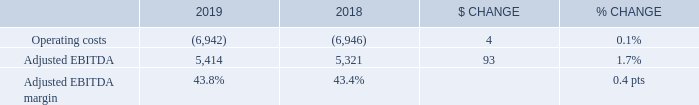OPERATING COSTS AND ADJUSTED EBITDA
Bell Wireline operating costs were essentially stable year over year, decreasing by 0.1% in 2019, compared to 2018, resulting from: • The favourable impact from the adoption of IFRS 16 in 2019 • Continued effective cost containment • Lower pension expenses reflecting reduced DB costs
These factors were partly offset by: • Higher cost of goods sold related to the growth in product sales • Increased costs from the acquisition of Axia • Greater payments to other carriers from increased sales of international wholesale long distance minutes
Bell Wireline adjusted EBITDA grew by 1.7% in 2019, compared to last year, reflecting the growth in revenues as operating expenses were relatively stable year over year. Adjusted EBITDA margin increased to 43.8% in 2019, compared to the 43.4% achieved last year, resulting from the favourable impact of the adoption of IFRS 16 in 2019 and the flow-through of the service revenue growth, offset in part by higher low-margin product sales in our total revenue base.
What are the favourable impact from the adoption of IFRS 16? Continued effective cost containment, lower pension expenses reflecting reduced db costs. What is the % change in operating costs from 2018 to 2019? 0.1%. What is the % change in the adjusted EBITDA margin from 2018 to 2019? 0.4 pts. What is the sum of the adjusted EBITDA in 2018 and 2019? 5,414+5,321
Answer: 10735. What is the sum of the operating costs in 2018 and 2019? -6,942+-6,946
Answer: -13888. What is the percentage of the 2019 adjusted EBITDA over the sum of the adjusted EBITDA in 2018 and 2019? 
Answer scale should be: percent. 5,414/(5,414+5,321)
Answer: 50.43. 